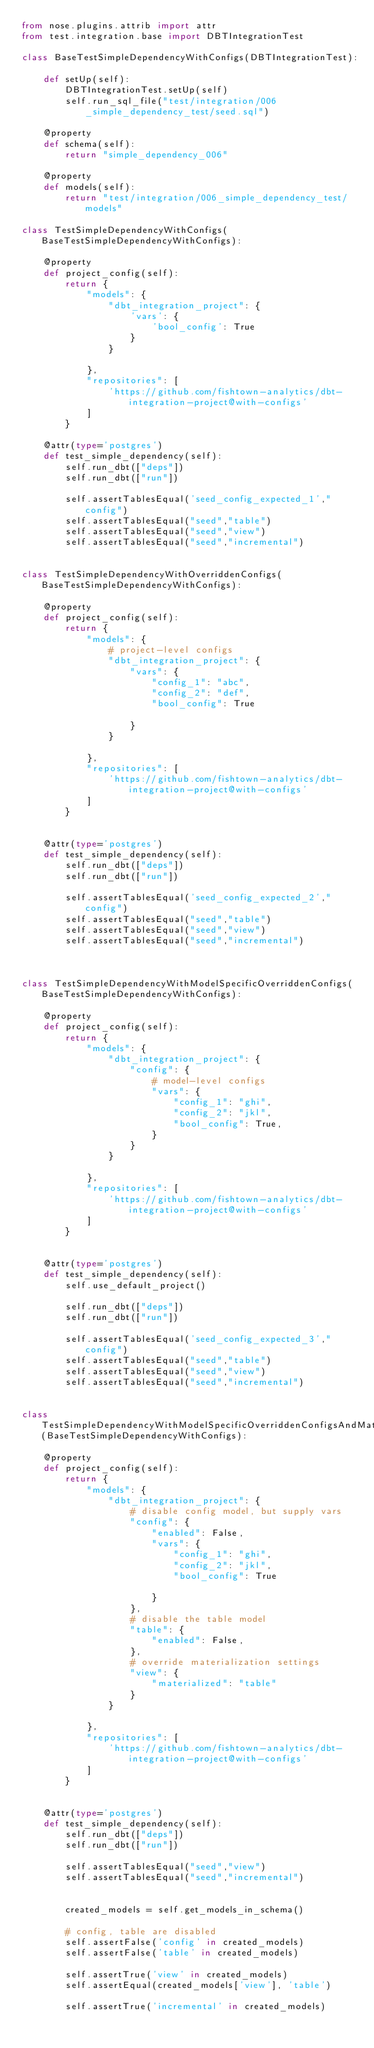Convert code to text. <code><loc_0><loc_0><loc_500><loc_500><_Python_>from nose.plugins.attrib import attr
from test.integration.base import DBTIntegrationTest

class BaseTestSimpleDependencyWithConfigs(DBTIntegrationTest):

    def setUp(self):
        DBTIntegrationTest.setUp(self)
        self.run_sql_file("test/integration/006_simple_dependency_test/seed.sql")

    @property
    def schema(self):
        return "simple_dependency_006"

    @property
    def models(self):
        return "test/integration/006_simple_dependency_test/models"

class TestSimpleDependencyWithConfigs(BaseTestSimpleDependencyWithConfigs):

    @property
    def project_config(self):
        return {
            "models": {
                "dbt_integration_project": {
                    'vars': {
                        'bool_config': True
                    }
                }

            },
            "repositories": [
                'https://github.com/fishtown-analytics/dbt-integration-project@with-configs'
            ]
        }

    @attr(type='postgres')
    def test_simple_dependency(self):
        self.run_dbt(["deps"])
        self.run_dbt(["run"])

        self.assertTablesEqual('seed_config_expected_1',"config")
        self.assertTablesEqual("seed","table")
        self.assertTablesEqual("seed","view")
        self.assertTablesEqual("seed","incremental")


class TestSimpleDependencyWithOverriddenConfigs(BaseTestSimpleDependencyWithConfigs):

    @property
    def project_config(self):
        return {
            "models": {
                # project-level configs
                "dbt_integration_project": {
                    "vars": {
                        "config_1": "abc",
                        "config_2": "def",
                        "bool_config": True

                    }
                }

            },
            "repositories": [
                'https://github.com/fishtown-analytics/dbt-integration-project@with-configs'
            ]
        }


    @attr(type='postgres')
    def test_simple_dependency(self):
        self.run_dbt(["deps"])
        self.run_dbt(["run"])

        self.assertTablesEqual('seed_config_expected_2',"config")
        self.assertTablesEqual("seed","table")
        self.assertTablesEqual("seed","view")
        self.assertTablesEqual("seed","incremental")



class TestSimpleDependencyWithModelSpecificOverriddenConfigs(BaseTestSimpleDependencyWithConfigs):

    @property
    def project_config(self):
        return {
            "models": {
                "dbt_integration_project": {
                    "config": {
                        # model-level configs
                        "vars": {
                            "config_1": "ghi",
                            "config_2": "jkl",
                            "bool_config": True,
                        }
                    }
                }

            },
            "repositories": [
                'https://github.com/fishtown-analytics/dbt-integration-project@with-configs'
            ]
        }


    @attr(type='postgres')
    def test_simple_dependency(self):
        self.use_default_project()

        self.run_dbt(["deps"])
        self.run_dbt(["run"])

        self.assertTablesEqual('seed_config_expected_3',"config")
        self.assertTablesEqual("seed","table")
        self.assertTablesEqual("seed","view")
        self.assertTablesEqual("seed","incremental")


class TestSimpleDependencyWithModelSpecificOverriddenConfigsAndMaterializations(BaseTestSimpleDependencyWithConfigs):

    @property
    def project_config(self):
        return {
            "models": {
                "dbt_integration_project": {
                    # disable config model, but supply vars
                    "config": {
                        "enabled": False,
                        "vars": {
                            "config_1": "ghi",
                            "config_2": "jkl",
                            "bool_config": True

                        }
                    },
                    # disable the table model
                    "table": {
                        "enabled": False,
                    },
                    # override materialization settings
                    "view": {
                        "materialized": "table"
                    }
                }

            },
            "repositories": [
                'https://github.com/fishtown-analytics/dbt-integration-project@with-configs'
            ]
        }


    @attr(type='postgres')
    def test_simple_dependency(self):
        self.run_dbt(["deps"])
        self.run_dbt(["run"])

        self.assertTablesEqual("seed","view")
        self.assertTablesEqual("seed","incremental")


        created_models = self.get_models_in_schema()

        # config, table are disabled
        self.assertFalse('config' in created_models)
        self.assertFalse('table' in created_models)

        self.assertTrue('view' in created_models)
        self.assertEqual(created_models['view'], 'table')

        self.assertTrue('incremental' in created_models)</code> 